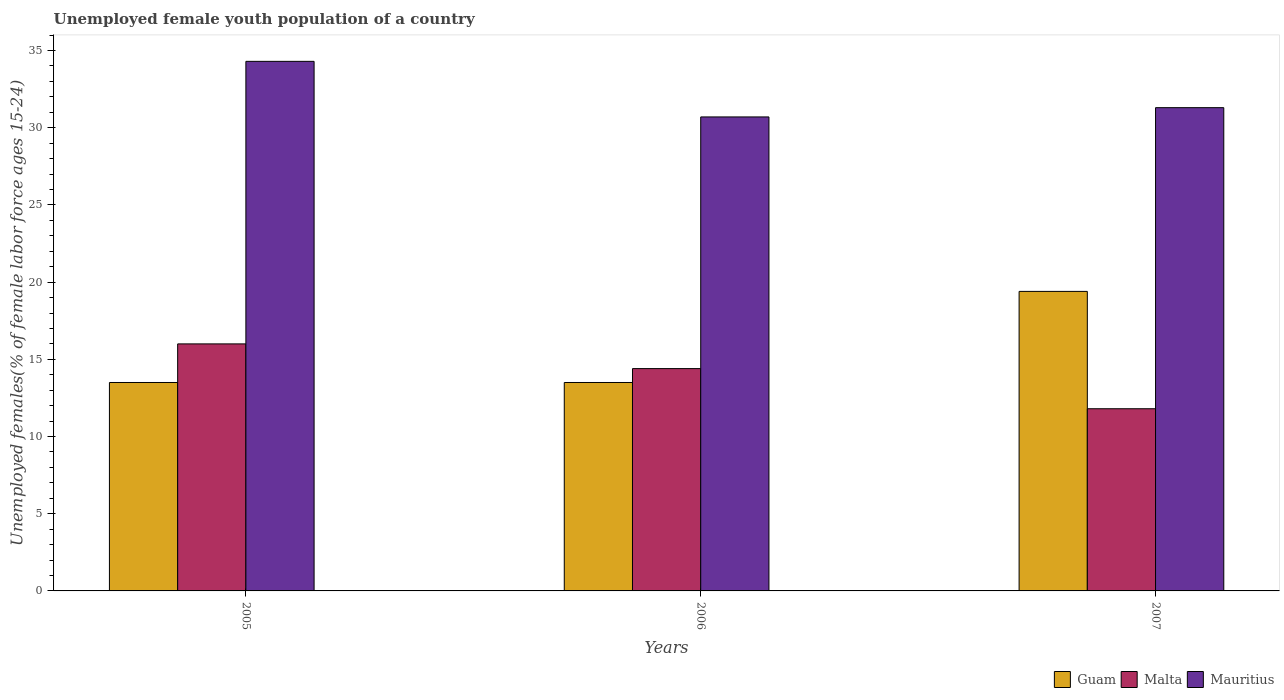How many different coloured bars are there?
Offer a very short reply. 3. How many groups of bars are there?
Your answer should be compact. 3. Are the number of bars per tick equal to the number of legend labels?
Offer a terse response. Yes. How many bars are there on the 2nd tick from the right?
Your answer should be very brief. 3. What is the label of the 3rd group of bars from the left?
Make the answer very short. 2007. In how many cases, is the number of bars for a given year not equal to the number of legend labels?
Your answer should be compact. 0. What is the percentage of unemployed female youth population in Malta in 2007?
Provide a short and direct response. 11.8. Across all years, what is the maximum percentage of unemployed female youth population in Malta?
Make the answer very short. 16. Across all years, what is the minimum percentage of unemployed female youth population in Malta?
Provide a short and direct response. 11.8. In which year was the percentage of unemployed female youth population in Malta maximum?
Provide a short and direct response. 2005. What is the total percentage of unemployed female youth population in Mauritius in the graph?
Keep it short and to the point. 96.3. What is the difference between the percentage of unemployed female youth population in Malta in 2005 and that in 2006?
Make the answer very short. 1.6. What is the difference between the percentage of unemployed female youth population in Malta in 2005 and the percentage of unemployed female youth population in Mauritius in 2006?
Keep it short and to the point. -14.7. What is the average percentage of unemployed female youth population in Guam per year?
Provide a short and direct response. 15.47. In the year 2005, what is the difference between the percentage of unemployed female youth population in Guam and percentage of unemployed female youth population in Mauritius?
Offer a terse response. -20.8. In how many years, is the percentage of unemployed female youth population in Guam greater than 23 %?
Give a very brief answer. 0. What is the ratio of the percentage of unemployed female youth population in Guam in 2005 to that in 2007?
Make the answer very short. 0.7. What is the difference between the highest and the second highest percentage of unemployed female youth population in Malta?
Your answer should be compact. 1.6. What is the difference between the highest and the lowest percentage of unemployed female youth population in Mauritius?
Your answer should be compact. 3.6. In how many years, is the percentage of unemployed female youth population in Mauritius greater than the average percentage of unemployed female youth population in Mauritius taken over all years?
Give a very brief answer. 1. Is the sum of the percentage of unemployed female youth population in Guam in 2006 and 2007 greater than the maximum percentage of unemployed female youth population in Mauritius across all years?
Make the answer very short. No. What does the 3rd bar from the left in 2005 represents?
Ensure brevity in your answer.  Mauritius. What does the 1st bar from the right in 2006 represents?
Give a very brief answer. Mauritius. Is it the case that in every year, the sum of the percentage of unemployed female youth population in Malta and percentage of unemployed female youth population in Guam is greater than the percentage of unemployed female youth population in Mauritius?
Your answer should be compact. No. How many bars are there?
Make the answer very short. 9. Are all the bars in the graph horizontal?
Keep it short and to the point. No. Does the graph contain grids?
Give a very brief answer. No. How many legend labels are there?
Provide a succinct answer. 3. How are the legend labels stacked?
Provide a short and direct response. Horizontal. What is the title of the graph?
Provide a succinct answer. Unemployed female youth population of a country. What is the label or title of the X-axis?
Provide a succinct answer. Years. What is the label or title of the Y-axis?
Your answer should be very brief. Unemployed females(% of female labor force ages 15-24). What is the Unemployed females(% of female labor force ages 15-24) in Guam in 2005?
Your response must be concise. 13.5. What is the Unemployed females(% of female labor force ages 15-24) in Mauritius in 2005?
Your answer should be compact. 34.3. What is the Unemployed females(% of female labor force ages 15-24) in Malta in 2006?
Ensure brevity in your answer.  14.4. What is the Unemployed females(% of female labor force ages 15-24) of Mauritius in 2006?
Offer a terse response. 30.7. What is the Unemployed females(% of female labor force ages 15-24) of Guam in 2007?
Offer a terse response. 19.4. What is the Unemployed females(% of female labor force ages 15-24) in Malta in 2007?
Make the answer very short. 11.8. What is the Unemployed females(% of female labor force ages 15-24) of Mauritius in 2007?
Keep it short and to the point. 31.3. Across all years, what is the maximum Unemployed females(% of female labor force ages 15-24) in Guam?
Ensure brevity in your answer.  19.4. Across all years, what is the maximum Unemployed females(% of female labor force ages 15-24) of Malta?
Ensure brevity in your answer.  16. Across all years, what is the maximum Unemployed females(% of female labor force ages 15-24) in Mauritius?
Give a very brief answer. 34.3. Across all years, what is the minimum Unemployed females(% of female labor force ages 15-24) of Guam?
Offer a terse response. 13.5. Across all years, what is the minimum Unemployed females(% of female labor force ages 15-24) in Malta?
Your answer should be compact. 11.8. Across all years, what is the minimum Unemployed females(% of female labor force ages 15-24) in Mauritius?
Give a very brief answer. 30.7. What is the total Unemployed females(% of female labor force ages 15-24) of Guam in the graph?
Make the answer very short. 46.4. What is the total Unemployed females(% of female labor force ages 15-24) of Malta in the graph?
Your answer should be compact. 42.2. What is the total Unemployed females(% of female labor force ages 15-24) in Mauritius in the graph?
Provide a short and direct response. 96.3. What is the difference between the Unemployed females(% of female labor force ages 15-24) in Malta in 2005 and that in 2007?
Provide a short and direct response. 4.2. What is the difference between the Unemployed females(% of female labor force ages 15-24) of Mauritius in 2005 and that in 2007?
Make the answer very short. 3. What is the difference between the Unemployed females(% of female labor force ages 15-24) of Guam in 2005 and the Unemployed females(% of female labor force ages 15-24) of Mauritius in 2006?
Offer a very short reply. -17.2. What is the difference between the Unemployed females(% of female labor force ages 15-24) in Malta in 2005 and the Unemployed females(% of female labor force ages 15-24) in Mauritius in 2006?
Provide a succinct answer. -14.7. What is the difference between the Unemployed females(% of female labor force ages 15-24) of Guam in 2005 and the Unemployed females(% of female labor force ages 15-24) of Mauritius in 2007?
Give a very brief answer. -17.8. What is the difference between the Unemployed females(% of female labor force ages 15-24) in Malta in 2005 and the Unemployed females(% of female labor force ages 15-24) in Mauritius in 2007?
Make the answer very short. -15.3. What is the difference between the Unemployed females(% of female labor force ages 15-24) of Guam in 2006 and the Unemployed females(% of female labor force ages 15-24) of Mauritius in 2007?
Your answer should be very brief. -17.8. What is the difference between the Unemployed females(% of female labor force ages 15-24) in Malta in 2006 and the Unemployed females(% of female labor force ages 15-24) in Mauritius in 2007?
Your response must be concise. -16.9. What is the average Unemployed females(% of female labor force ages 15-24) of Guam per year?
Offer a very short reply. 15.47. What is the average Unemployed females(% of female labor force ages 15-24) in Malta per year?
Ensure brevity in your answer.  14.07. What is the average Unemployed females(% of female labor force ages 15-24) of Mauritius per year?
Provide a succinct answer. 32.1. In the year 2005, what is the difference between the Unemployed females(% of female labor force ages 15-24) of Guam and Unemployed females(% of female labor force ages 15-24) of Malta?
Give a very brief answer. -2.5. In the year 2005, what is the difference between the Unemployed females(% of female labor force ages 15-24) of Guam and Unemployed females(% of female labor force ages 15-24) of Mauritius?
Keep it short and to the point. -20.8. In the year 2005, what is the difference between the Unemployed females(% of female labor force ages 15-24) of Malta and Unemployed females(% of female labor force ages 15-24) of Mauritius?
Ensure brevity in your answer.  -18.3. In the year 2006, what is the difference between the Unemployed females(% of female labor force ages 15-24) of Guam and Unemployed females(% of female labor force ages 15-24) of Malta?
Provide a short and direct response. -0.9. In the year 2006, what is the difference between the Unemployed females(% of female labor force ages 15-24) of Guam and Unemployed females(% of female labor force ages 15-24) of Mauritius?
Your answer should be very brief. -17.2. In the year 2006, what is the difference between the Unemployed females(% of female labor force ages 15-24) of Malta and Unemployed females(% of female labor force ages 15-24) of Mauritius?
Your answer should be very brief. -16.3. In the year 2007, what is the difference between the Unemployed females(% of female labor force ages 15-24) in Guam and Unemployed females(% of female labor force ages 15-24) in Mauritius?
Ensure brevity in your answer.  -11.9. In the year 2007, what is the difference between the Unemployed females(% of female labor force ages 15-24) of Malta and Unemployed females(% of female labor force ages 15-24) of Mauritius?
Keep it short and to the point. -19.5. What is the ratio of the Unemployed females(% of female labor force ages 15-24) of Malta in 2005 to that in 2006?
Ensure brevity in your answer.  1.11. What is the ratio of the Unemployed females(% of female labor force ages 15-24) of Mauritius in 2005 to that in 2006?
Provide a succinct answer. 1.12. What is the ratio of the Unemployed females(% of female labor force ages 15-24) in Guam in 2005 to that in 2007?
Provide a succinct answer. 0.7. What is the ratio of the Unemployed females(% of female labor force ages 15-24) of Malta in 2005 to that in 2007?
Offer a terse response. 1.36. What is the ratio of the Unemployed females(% of female labor force ages 15-24) of Mauritius in 2005 to that in 2007?
Offer a very short reply. 1.1. What is the ratio of the Unemployed females(% of female labor force ages 15-24) in Guam in 2006 to that in 2007?
Make the answer very short. 0.7. What is the ratio of the Unemployed females(% of female labor force ages 15-24) of Malta in 2006 to that in 2007?
Your answer should be very brief. 1.22. What is the ratio of the Unemployed females(% of female labor force ages 15-24) in Mauritius in 2006 to that in 2007?
Offer a terse response. 0.98. What is the difference between the highest and the second highest Unemployed females(% of female labor force ages 15-24) of Mauritius?
Your answer should be very brief. 3. What is the difference between the highest and the lowest Unemployed females(% of female labor force ages 15-24) of Mauritius?
Your response must be concise. 3.6. 